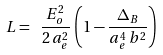Convert formula to latex. <formula><loc_0><loc_0><loc_500><loc_500>L = \ \frac { E _ { o } ^ { 2 } } { 2 \, a _ { e } ^ { 2 } } \, \left ( 1 - \frac { \Delta _ { B } } { a _ { e } ^ { 4 } \, b ^ { 2 } } \right )</formula> 